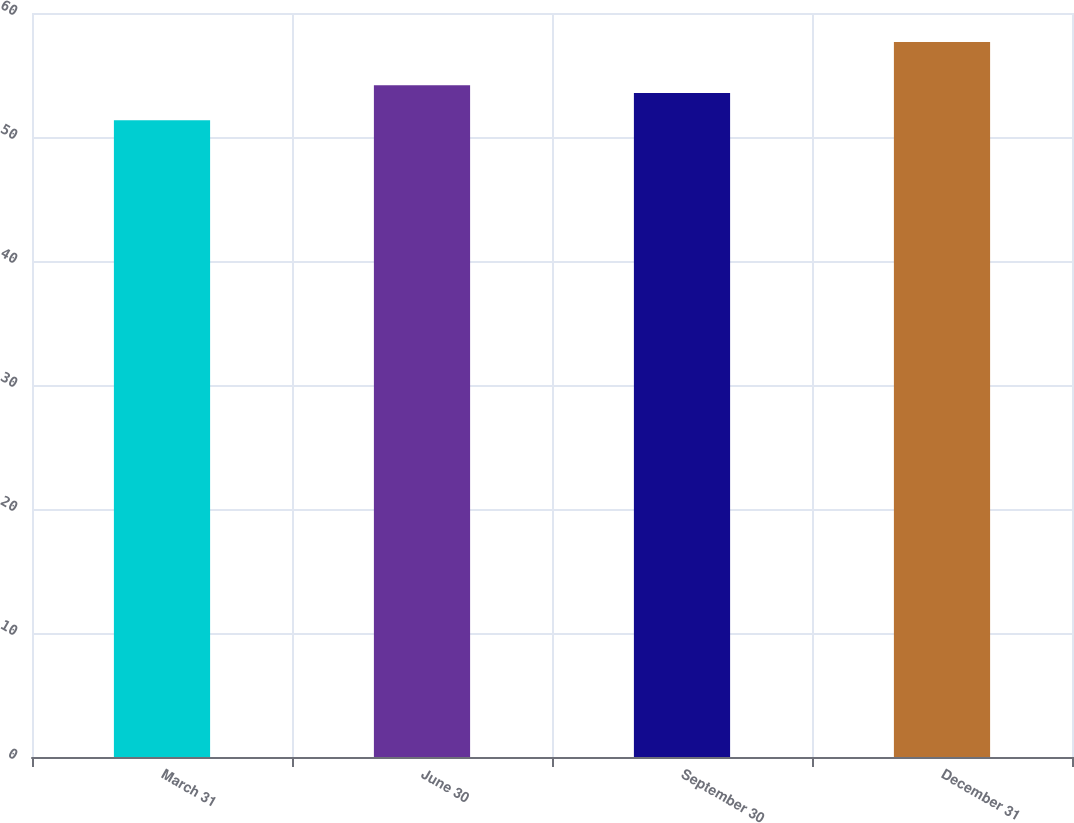<chart> <loc_0><loc_0><loc_500><loc_500><bar_chart><fcel>March 31<fcel>June 30<fcel>September 30<fcel>December 31<nl><fcel>51.35<fcel>54.17<fcel>53.54<fcel>57.67<nl></chart> 